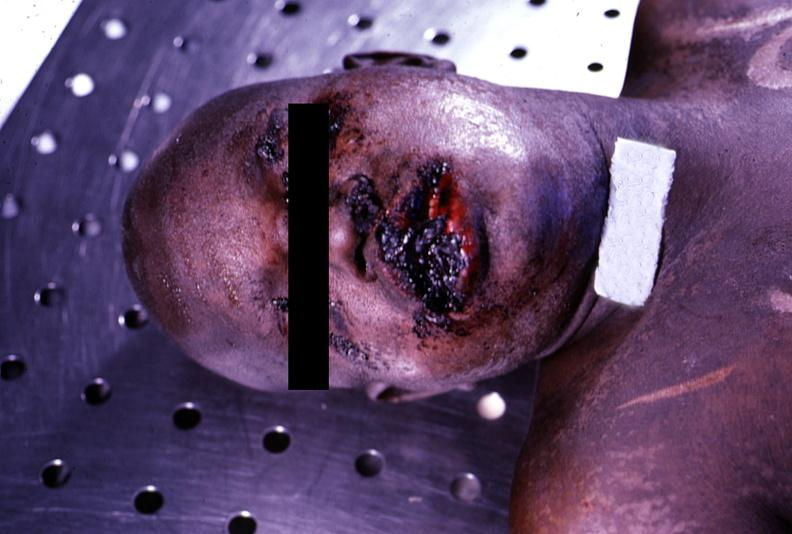what does this image show?
Answer the question using a single word or phrase. Ulcerations 